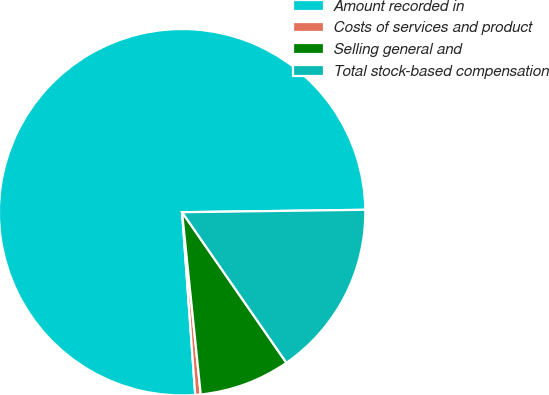Convert chart to OTSL. <chart><loc_0><loc_0><loc_500><loc_500><pie_chart><fcel>Amount recorded in<fcel>Costs of services and product<fcel>Selling general and<fcel>Total stock-based compensation<nl><fcel>75.93%<fcel>0.48%<fcel>8.02%<fcel>15.57%<nl></chart> 